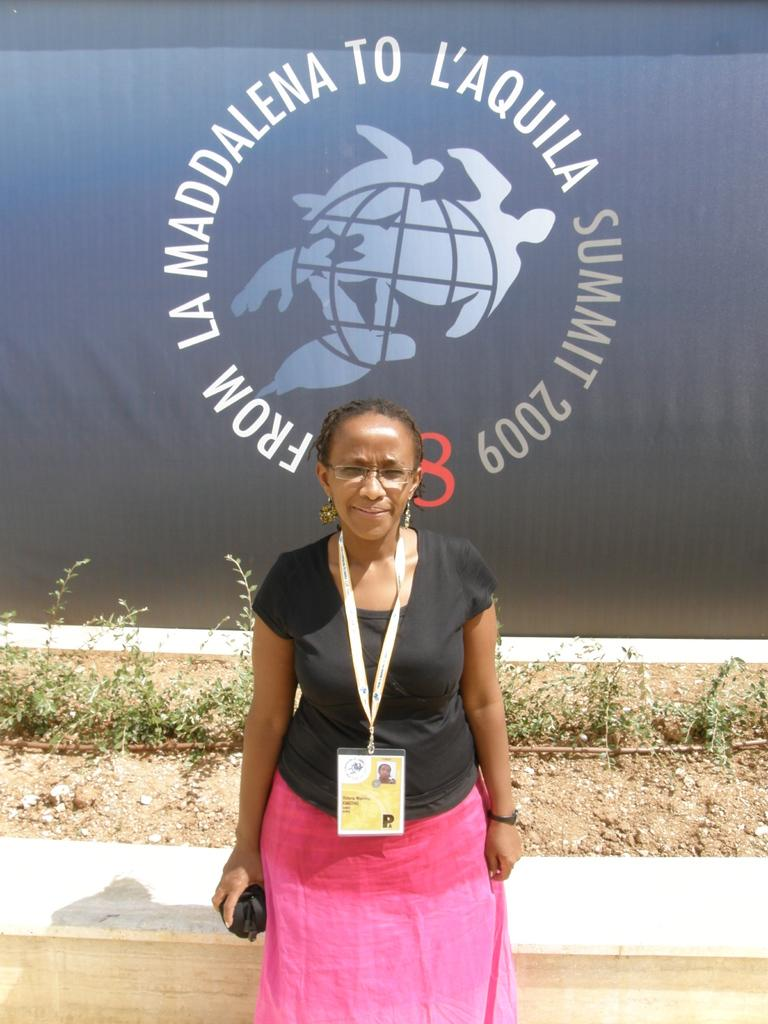What is the main subject of the image? There is a woman standing in the image. Can you describe any specific details about the woman? The woman is wearing a tag. What can be seen behind the woman? There is a wall visible behind the woman. What is present in the background of the image? There are plants and a banner in the background of the image. What language is the woman speaking in the image? The image does not provide any information about the language being spoken, as there is no audio or text present. 